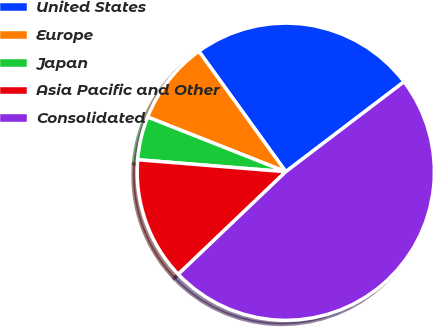Convert chart to OTSL. <chart><loc_0><loc_0><loc_500><loc_500><pie_chart><fcel>United States<fcel>Europe<fcel>Japan<fcel>Asia Pacific and Other<fcel>Consolidated<nl><fcel>24.6%<fcel>9.06%<fcel>4.71%<fcel>13.41%<fcel>48.23%<nl></chart> 